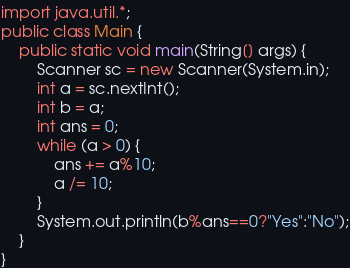Convert code to text. <code><loc_0><loc_0><loc_500><loc_500><_Java_>import java.util.*;
public class Main {
    public static void main(String[] args) {
        Scanner sc = new Scanner(System.in);
        int a = sc.nextInt();
        int b = a;
        int ans = 0;
        while (a > 0) {
            ans += a%10;
            a /= 10;
        }
        System.out.println(b%ans==0?"Yes":"No");
    }
}</code> 